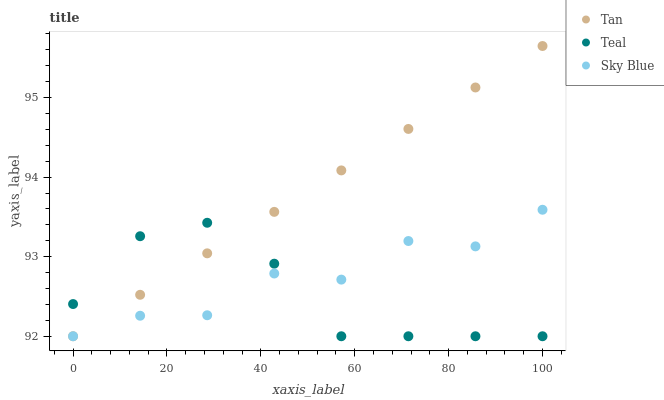Does Teal have the minimum area under the curve?
Answer yes or no. Yes. Does Tan have the maximum area under the curve?
Answer yes or no. Yes. Does Tan have the minimum area under the curve?
Answer yes or no. No. Does Teal have the maximum area under the curve?
Answer yes or no. No. Is Tan the smoothest?
Answer yes or no. Yes. Is Sky Blue the roughest?
Answer yes or no. Yes. Is Teal the smoothest?
Answer yes or no. No. Is Teal the roughest?
Answer yes or no. No. Does Sky Blue have the lowest value?
Answer yes or no. Yes. Does Tan have the highest value?
Answer yes or no. Yes. Does Teal have the highest value?
Answer yes or no. No. Does Tan intersect Sky Blue?
Answer yes or no. Yes. Is Tan less than Sky Blue?
Answer yes or no. No. Is Tan greater than Sky Blue?
Answer yes or no. No. 